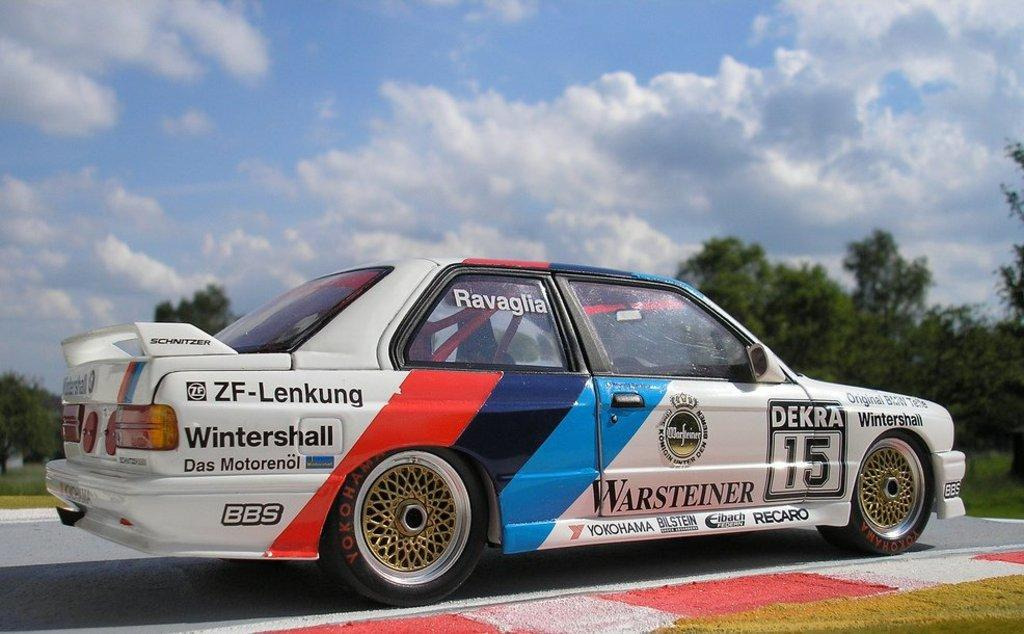What is the main subject of the image? There is a car on the road in the image. What can be seen in the background of the image? There are trees in the background of the image. What is visible above the trees in the image? The sky is visible in the image. What can be observed in the sky? Clouds are present in the sky. What type of shoe is hanging from the tree in the image? There is no shoe hanging from the tree in the image; there are only trees visible in the background. 